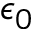<formula> <loc_0><loc_0><loc_500><loc_500>\epsilon _ { 0 }</formula> 